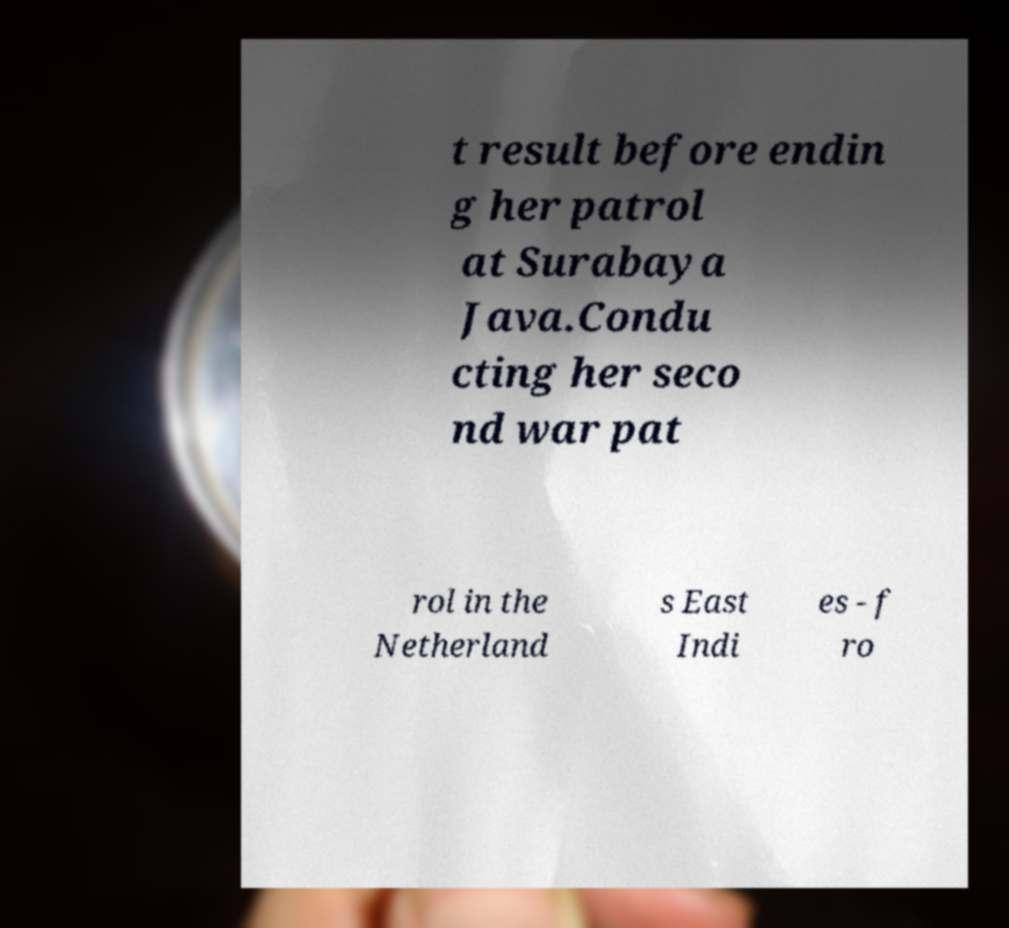What messages or text are displayed in this image? I need them in a readable, typed format. t result before endin g her patrol at Surabaya Java.Condu cting her seco nd war pat rol in the Netherland s East Indi es - f ro 